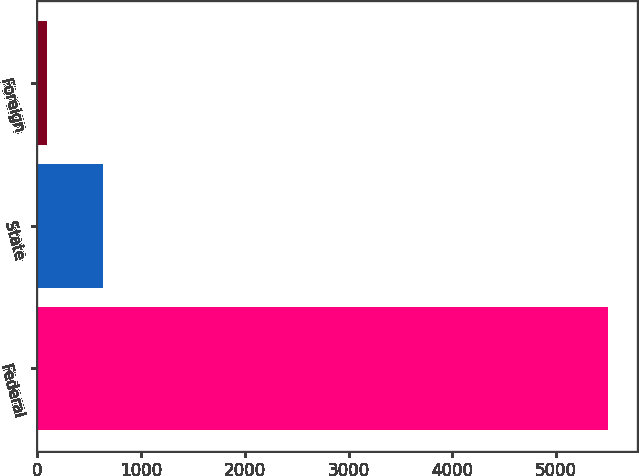Convert chart. <chart><loc_0><loc_0><loc_500><loc_500><bar_chart><fcel>Federal<fcel>State<fcel>Foreign<nl><fcel>5501<fcel>636.5<fcel>96<nl></chart> 